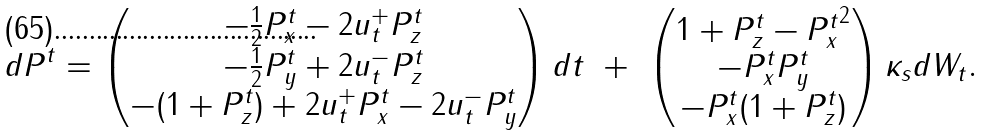Convert formula to latex. <formula><loc_0><loc_0><loc_500><loc_500>d { P } ^ { t } = \begin{pmatrix} - \frac { 1 } { 2 } P ^ { t } _ { x } - 2 u ^ { + } _ { t } P ^ { t } _ { z } \\ - \frac { 1 } { 2 } P ^ { t } _ { y } + 2 u ^ { - } _ { t } P ^ { t } _ { z } \\ - ( 1 + P ^ { t } _ { z } ) + 2 u ^ { + } _ { t } P ^ { t } _ { x } - 2 u ^ { - } _ { t } P ^ { t } _ { y } \end{pmatrix} d t \ + \ \begin{pmatrix} 1 + P ^ { t } _ { z } - { P ^ { t } _ { x } } ^ { 2 } \\ - P ^ { t } _ { x } P ^ { t } _ { y } \\ - P ^ { t } _ { x } ( 1 + P ^ { t } _ { z } ) \end{pmatrix} \kappa _ { s } d W _ { t } .</formula> 